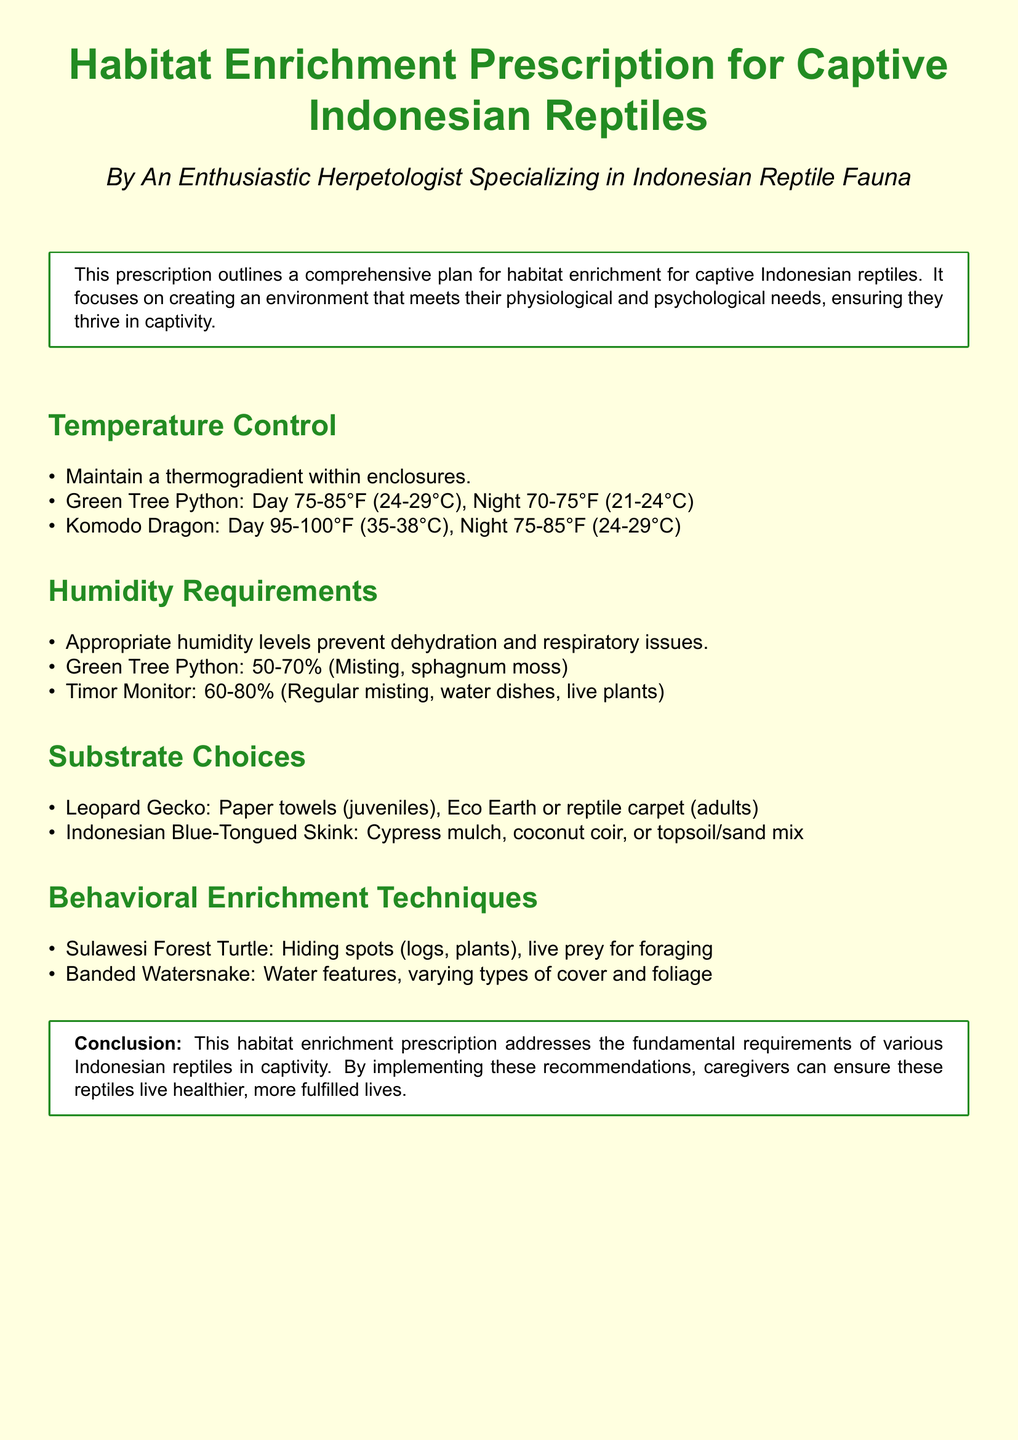what is the thermogradient range for Green Tree Pythons? The document specifies that Green Tree Pythons require a thermogradient of 75-85°F (24-29°C) during the day and 70-75°F (21-24°C) at night.
Answer: 75-85°F (24-29°C) what is the humidity requirement for Timor Monitors? According to the document, Timor Monitors need humidity levels of 60-80%.
Answer: 60-80% what substrate is recommended for Indonesian Blue-Tongued Skinks? The document mentions that Indonesian Blue-Tongued Skinks should have a substrate of cypress mulch, coconut coir, or topsoil/sand mix.
Answer: cypress mulch, coconut coir, or topsoil/sand mix which species requires hiding spots for behavioral enrichment? The document states that Sulawesi Forest Turtles benefit from hiding spots for their habitat enrichment.
Answer: Sulawesi Forest Turtle what is the purpose of appropriate humidity levels in reptile enclosures? Appropriate humidity levels are necessary to prevent dehydration and respiratory issues in reptiles, as outlined in the document.
Answer: prevent dehydration and respiratory issues what temperature range should Komodo Dragons experience at night? The document indicates that Komodo Dragons require a nighttime temperature of 75-85°F (24-29°C).
Answer: 75-85°F (24-29°C) which reptile species is mentioned to have behavioral enrichment involving live prey? The document highlights that the Sulawesi Forest Turtle utilizes live prey for foraging as part of its behavioral enrichment techniques.
Answer: Sulawesi Forest Turtle what type of enclosure feature is suggested for Banded Watersnakes? The document recommends water features and varying types of cover and foliage as part of the habitat for Banded Watersnakes.
Answer: water features, cover and foliage 